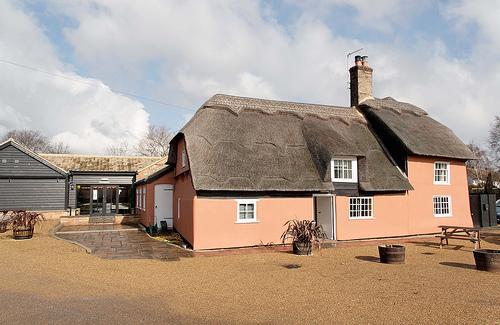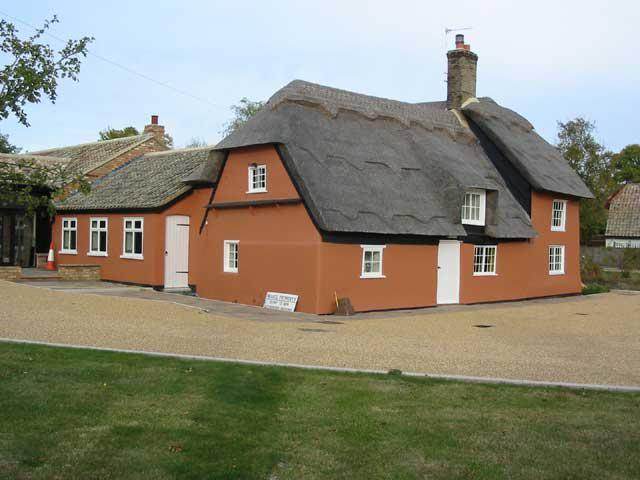The first image is the image on the left, the second image is the image on the right. Examine the images to the left and right. Is the description "The left image shows potted plants on a grassless surface in front of an orangish building with a curving 'cap' along the peak of the roof and a notch to accommodate a window." accurate? Answer yes or no. Yes. The first image is the image on the left, the second image is the image on the right. Given the left and right images, does the statement "In at least one image there is is a red rust house with a black roof and a single chimney on it." hold true? Answer yes or no. Yes. 